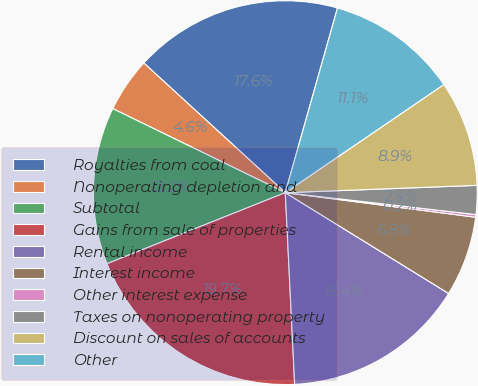Convert chart. <chart><loc_0><loc_0><loc_500><loc_500><pie_chart><fcel>Royalties from coal<fcel>Nonoperating depletion and<fcel>Subtotal<fcel>Gains from sale of properties<fcel>Rental income<fcel>Interest income<fcel>Other interest expense<fcel>Taxes on nonoperating property<fcel>Discount on sales of accounts<fcel>Other<nl><fcel>17.58%<fcel>4.59%<fcel>13.25%<fcel>19.74%<fcel>15.42%<fcel>6.76%<fcel>0.22%<fcel>2.43%<fcel>8.92%<fcel>11.09%<nl></chart> 